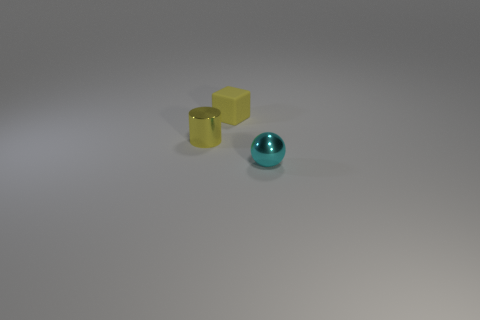What number of things are yellow things or yellow objects that are behind the small yellow metallic thing?
Ensure brevity in your answer.  2. There is a object in front of the cylinder; is its size the same as the metallic thing behind the cyan metal object?
Provide a succinct answer. Yes. What number of other objects are the same color as the tiny sphere?
Your answer should be compact. 0. There is a cyan metal ball; is it the same size as the metal object that is to the left of the small cube?
Give a very brief answer. Yes. There is a metallic object behind the small metallic thing right of the block; what is its size?
Your response must be concise. Small. Does the cyan shiny object have the same size as the cylinder?
Provide a succinct answer. Yes. Are there an equal number of tiny balls that are right of the cyan sphere and small yellow metal objects?
Provide a succinct answer. No. Are there any cyan objects that are on the right side of the shiny object that is on the left side of the metallic ball?
Offer a terse response. Yes. There is a thing that is on the left side of the yellow block that is behind the shiny object on the left side of the small shiny sphere; what size is it?
Offer a very short reply. Small. What is the small yellow thing to the right of the tiny shiny object that is left of the block made of?
Keep it short and to the point. Rubber. 